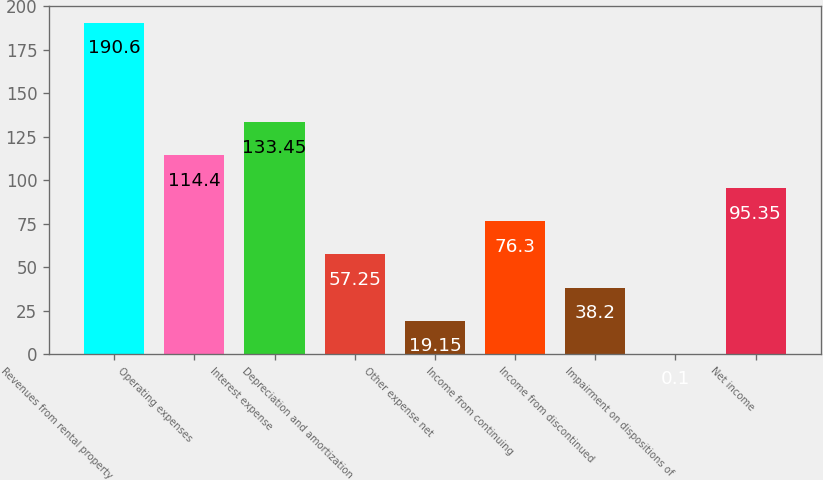Convert chart. <chart><loc_0><loc_0><loc_500><loc_500><bar_chart><fcel>Revenues from rental property<fcel>Operating expenses<fcel>Interest expense<fcel>Depreciation and amortization<fcel>Other expense net<fcel>Income from continuing<fcel>Income from discontinued<fcel>Impairment on dispositions of<fcel>Net income<nl><fcel>190.6<fcel>114.4<fcel>133.45<fcel>57.25<fcel>19.15<fcel>76.3<fcel>38.2<fcel>0.1<fcel>95.35<nl></chart> 